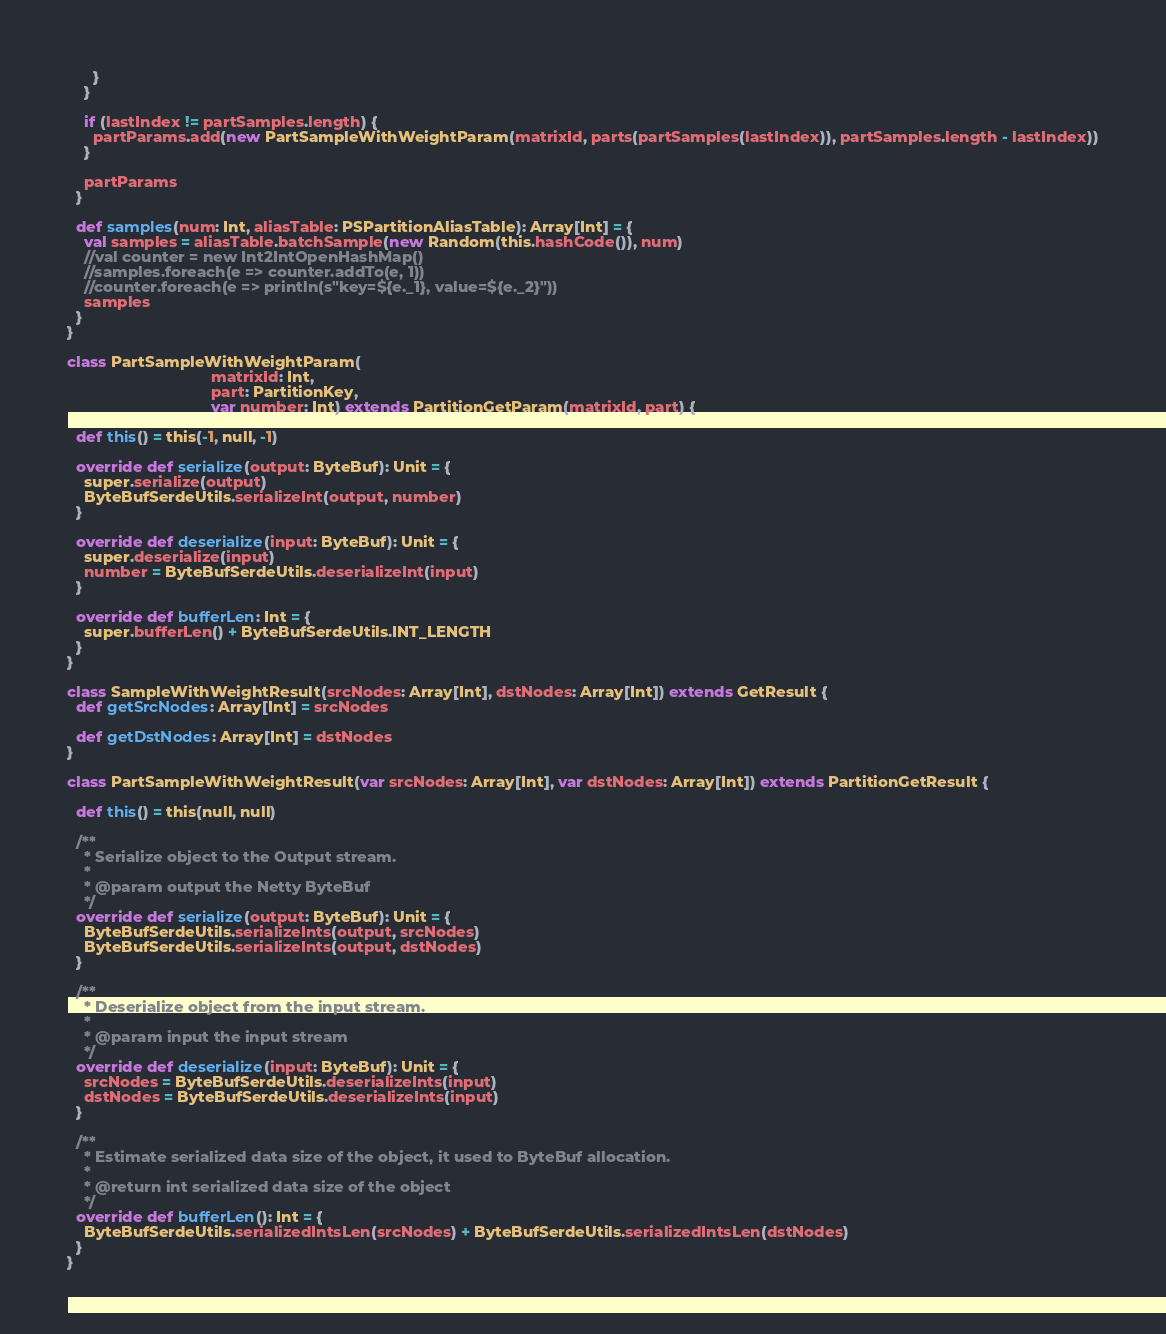<code> <loc_0><loc_0><loc_500><loc_500><_Scala_>      }
    }

    if (lastIndex != partSamples.length) {
      partParams.add(new PartSampleWithWeightParam(matrixId, parts(partSamples(lastIndex)), partSamples.length - lastIndex))
    }

    partParams
  }

  def samples(num: Int, aliasTable: PSPartitionAliasTable): Array[Int] = {
    val samples = aliasTable.batchSample(new Random(this.hashCode()), num)
    //val counter = new Int2IntOpenHashMap()
    //samples.foreach(e => counter.addTo(e, 1))
    //counter.foreach(e => println(s"key=${e._1}, value=${e._2}"))
    samples
  }
}

class PartSampleWithWeightParam(
                                 matrixId: Int,
                                 part: PartitionKey,
                                 var number: Int) extends PartitionGetParam(matrixId, part) {

  def this() = this(-1, null, -1)

  override def serialize(output: ByteBuf): Unit = {
    super.serialize(output)
    ByteBufSerdeUtils.serializeInt(output, number)
  }

  override def deserialize(input: ByteBuf): Unit = {
    super.deserialize(input)
    number = ByteBufSerdeUtils.deserializeInt(input)
  }

  override def bufferLen: Int = {
    super.bufferLen() + ByteBufSerdeUtils.INT_LENGTH
  }
}

class SampleWithWeightResult(srcNodes: Array[Int], dstNodes: Array[Int]) extends GetResult {
  def getSrcNodes: Array[Int] = srcNodes

  def getDstNodes: Array[Int] = dstNodes
}

class PartSampleWithWeightResult(var srcNodes: Array[Int], var dstNodes: Array[Int]) extends PartitionGetResult {

  def this() = this(null, null)

  /**
    * Serialize object to the Output stream.
    *
    * @param output the Netty ByteBuf
    */
  override def serialize(output: ByteBuf): Unit = {
    ByteBufSerdeUtils.serializeInts(output, srcNodes)
    ByteBufSerdeUtils.serializeInts(output, dstNodes)
  }

  /**
    * Deserialize object from the input stream.
    *
    * @param input the input stream
    */
  override def deserialize(input: ByteBuf): Unit = {
    srcNodes = ByteBufSerdeUtils.deserializeInts(input)
    dstNodes = ByteBufSerdeUtils.deserializeInts(input)
  }

  /**
    * Estimate serialized data size of the object, it used to ByteBuf allocation.
    *
    * @return int serialized data size of the object
    */
  override def bufferLen(): Int = {
    ByteBufSerdeUtils.serializedIntsLen(srcNodes) + ByteBufSerdeUtils.serializedIntsLen(dstNodes)
  }
}
</code> 